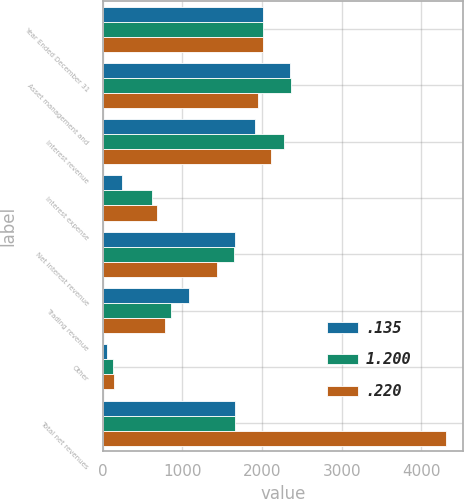<chart> <loc_0><loc_0><loc_500><loc_500><stacked_bar_chart><ecel><fcel>Year Ended December 31<fcel>Asset management and<fcel>Interest revenue<fcel>Interest expense<fcel>Net interest revenue<fcel>Trading revenue<fcel>Other<fcel>Total net revenues<nl><fcel>0.135<fcel>2008<fcel>2355<fcel>1908<fcel>243<fcel>1665<fcel>1080<fcel>50<fcel>1656<nl><fcel>1.2<fcel>2007<fcel>2358<fcel>2270<fcel>623<fcel>1647<fcel>860<fcel>129<fcel>1656<nl><fcel>0.22<fcel>2006<fcel>1945<fcel>2113<fcel>679<fcel>1434<fcel>785<fcel>145<fcel>4309<nl></chart> 